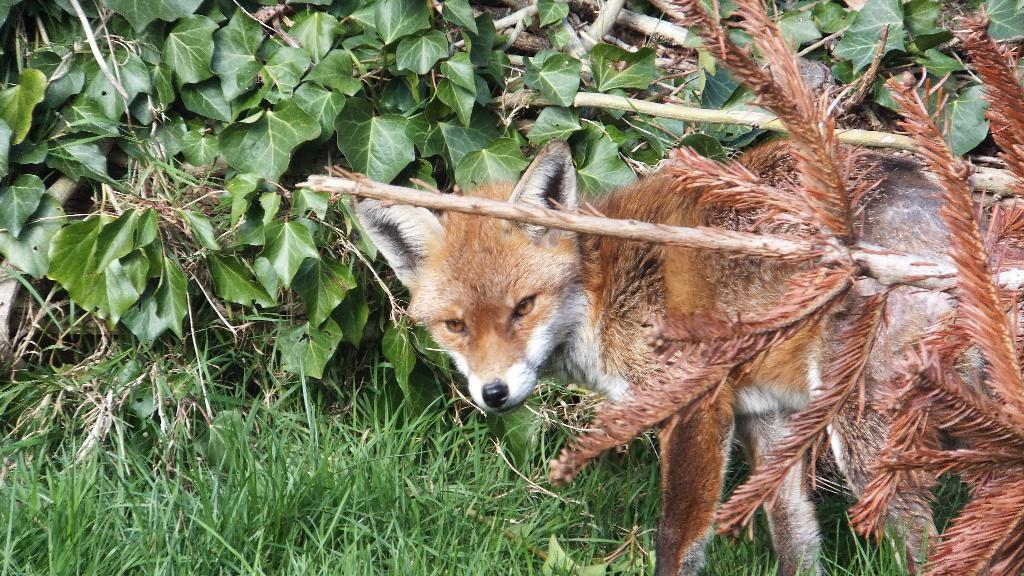What animal is present in the image? There is a fox in the image. Where is the fox located in relation to the plants and grass? The fox is standing near plants and grass. What type of vegetation can be seen on the right side of the image? There are bamboos on the right side of the image. What type of vegetation can be seen on the left side of the image? There are many leaves on the left side of the image. What type of basketball skills does the writer demonstrate in the image? There is no writer or basketball present in the image; it features a fox standing near plants and grass. 